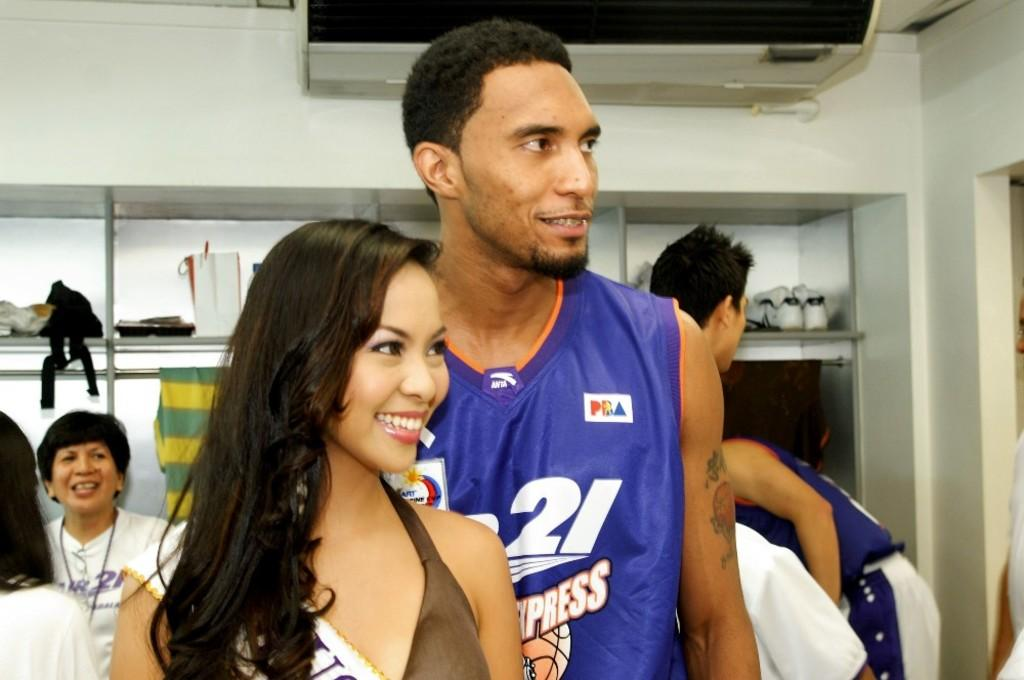<image>
Summarize the visual content of the image. A man in a purple jersey with the number 21 on it poses with a brunette woman 